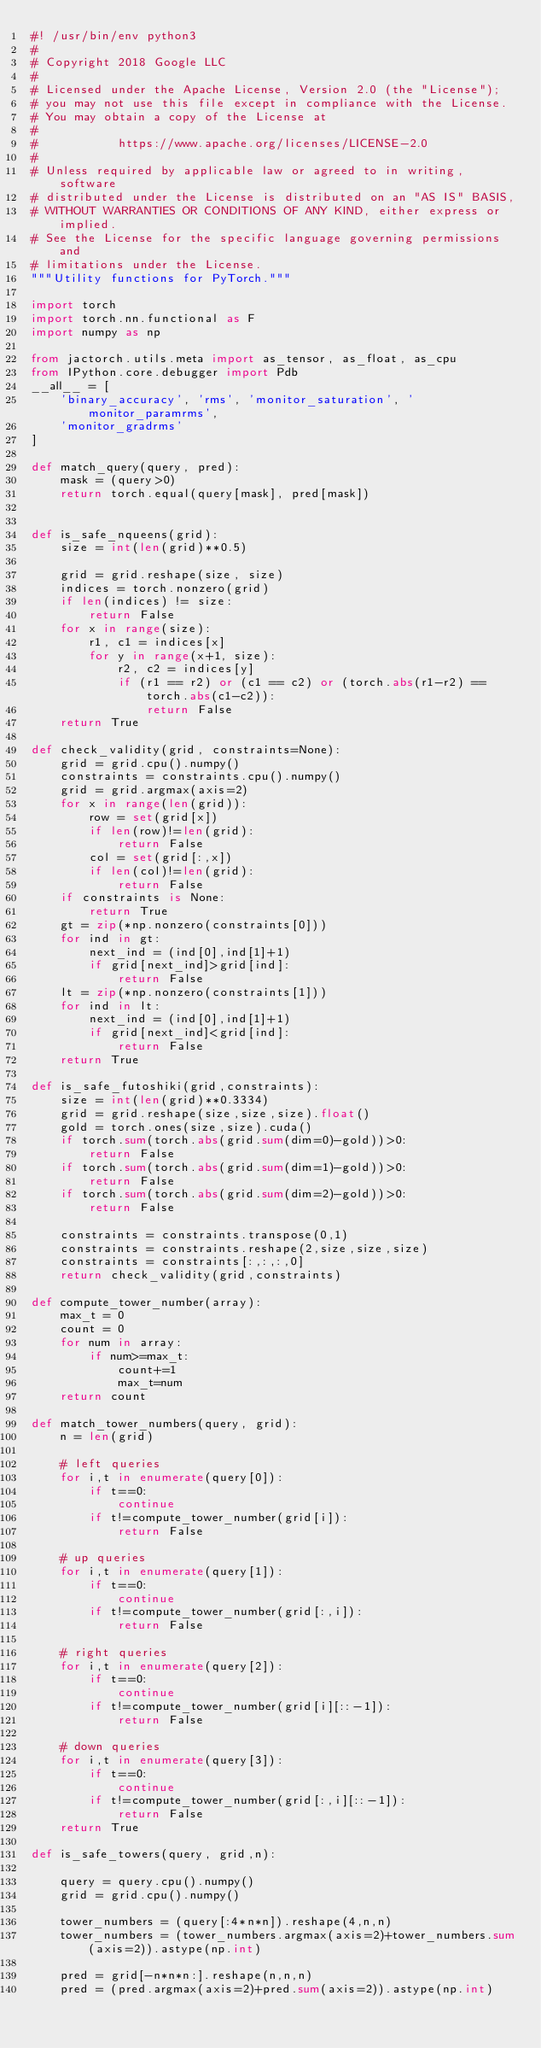Convert code to text. <code><loc_0><loc_0><loc_500><loc_500><_Python_>#! /usr/bin/env python3
#
# Copyright 2018 Google LLC
#
# Licensed under the Apache License, Version 2.0 (the "License");
# you may not use this file except in compliance with the License.
# You may obtain a copy of the License at
#
#           https://www.apache.org/licenses/LICENSE-2.0
#
# Unless required by applicable law or agreed to in writing, software
# distributed under the License is distributed on an "AS IS" BASIS,
# WITHOUT WARRANTIES OR CONDITIONS OF ANY KIND, either express or implied.
# See the License for the specific language governing permissions and
# limitations under the License.
"""Utility functions for PyTorch."""

import torch
import torch.nn.functional as F
import numpy as np

from jactorch.utils.meta import as_tensor, as_float, as_cpu
from IPython.core.debugger import Pdb
__all__ = [
    'binary_accuracy', 'rms', 'monitor_saturation', 'monitor_paramrms',
    'monitor_gradrms'
]

def match_query(query, pred):
    mask = (query>0)
    return torch.equal(query[mask], pred[mask])


def is_safe_nqueens(grid):
    size = int(len(grid)**0.5)

    grid = grid.reshape(size, size)
    indices = torch.nonzero(grid)
    if len(indices) != size:
        return False
    for x in range(size):
        r1, c1 = indices[x]
        for y in range(x+1, size):
            r2, c2 = indices[y]
            if (r1 == r2) or (c1 == c2) or (torch.abs(r1-r2) == torch.abs(c1-c2)):
                return False
    return True 

def check_validity(grid, constraints=None):
    grid = grid.cpu().numpy()
    constraints = constraints.cpu().numpy()
    grid = grid.argmax(axis=2)
    for x in range(len(grid)):
        row = set(grid[x])
        if len(row)!=len(grid):
            return False
        col = set(grid[:,x])
        if len(col)!=len(grid):
            return False
    if constraints is None:
        return True
    gt = zip(*np.nonzero(constraints[0]))
    for ind in gt:
        next_ind = (ind[0],ind[1]+1)
        if grid[next_ind]>grid[ind]:
            return False
    lt = zip(*np.nonzero(constraints[1]))
    for ind in lt:
        next_ind = (ind[0],ind[1]+1)
        if grid[next_ind]<grid[ind]:
            return False
    return True

def is_safe_futoshiki(grid,constraints):
    size = int(len(grid)**0.3334)
    grid = grid.reshape(size,size,size).float()
    gold = torch.ones(size,size).cuda()
    if torch.sum(torch.abs(grid.sum(dim=0)-gold))>0:
        return False
    if torch.sum(torch.abs(grid.sum(dim=1)-gold))>0:
        return False
    if torch.sum(torch.abs(grid.sum(dim=2)-gold))>0:
        return False
     
    constraints = constraints.transpose(0,1)
    constraints = constraints.reshape(2,size,size,size)
    constraints = constraints[:,:,:,0]
    return check_validity(grid,constraints)

def compute_tower_number(array):
    max_t = 0
    count = 0
    for num in array:
        if num>=max_t:
            count+=1
            max_t=num
    return count

def match_tower_numbers(query, grid):
    n = len(grid)

    # left queries
    for i,t in enumerate(query[0]):
        if t==0:
            continue
        if t!=compute_tower_number(grid[i]):
            return False

    # up queries
    for i,t in enumerate(query[1]):
        if t==0:
            continue
        if t!=compute_tower_number(grid[:,i]):
            return False

    # right queries
    for i,t in enumerate(query[2]):
        if t==0:
            continue
        if t!=compute_tower_number(grid[i][::-1]):
            return False

    # down queries
    for i,t in enumerate(query[3]):
        if t==0:
            continue
        if t!=compute_tower_number(grid[:,i][::-1]):
            return False
    return True

def is_safe_towers(query, grid,n):
    
    query = query.cpu().numpy()
    grid = grid.cpu().numpy()
    
    tower_numbers = (query[:4*n*n]).reshape(4,n,n)
    tower_numbers = (tower_numbers.argmax(axis=2)+tower_numbers.sum(axis=2)).astype(np.int)
    
    pred = grid[-n*n*n:].reshape(n,n,n)
    pred = (pred.argmax(axis=2)+pred.sum(axis=2)).astype(np.int)
    </code> 